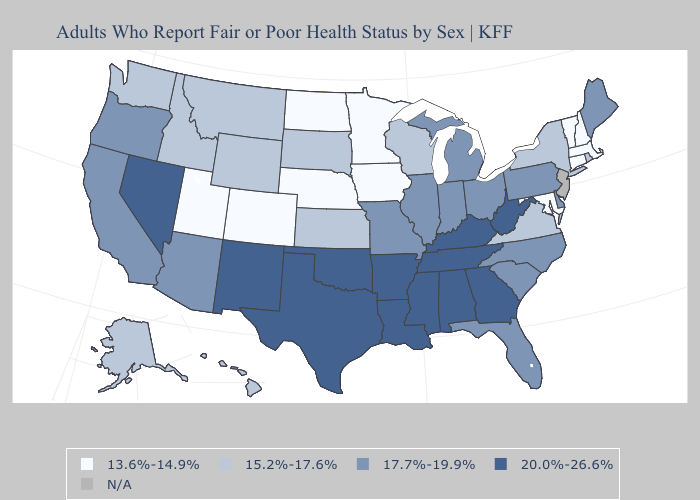Name the states that have a value in the range 15.2%-17.6%?
Be succinct. Alaska, Hawaii, Idaho, Kansas, Montana, New York, Rhode Island, South Dakota, Virginia, Washington, Wisconsin, Wyoming. What is the highest value in the South ?
Give a very brief answer. 20.0%-26.6%. What is the highest value in the West ?
Write a very short answer. 20.0%-26.6%. Among the states that border Florida , which have the highest value?
Write a very short answer. Alabama, Georgia. Among the states that border South Carolina , which have the highest value?
Answer briefly. Georgia. What is the value of Pennsylvania?
Answer briefly. 17.7%-19.9%. Which states have the lowest value in the South?
Quick response, please. Maryland. Among the states that border Rhode Island , which have the highest value?
Concise answer only. Connecticut, Massachusetts. Does Idaho have the highest value in the West?
Quick response, please. No. Name the states that have a value in the range N/A?
Keep it brief. New Jersey. Name the states that have a value in the range N/A?
Be succinct. New Jersey. Name the states that have a value in the range 17.7%-19.9%?
Short answer required. Arizona, California, Delaware, Florida, Illinois, Indiana, Maine, Michigan, Missouri, North Carolina, Ohio, Oregon, Pennsylvania, South Carolina. Name the states that have a value in the range N/A?
Be succinct. New Jersey. What is the highest value in states that border Florida?
Keep it brief. 20.0%-26.6%. 